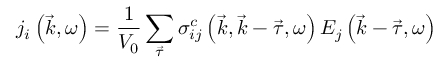<formula> <loc_0><loc_0><loc_500><loc_500>j _ { i } \left ( \vec { k } , \omega \right ) = \frac { 1 } V _ { 0 } } \sum _ { \vec { \tau } } \sigma _ { i j } ^ { c } \left ( \vec { k } , \vec { k } - \vec { \tau } , \omega \right ) E _ { j } \left ( \vec { k } - \vec { \tau } , \omega \right )</formula> 